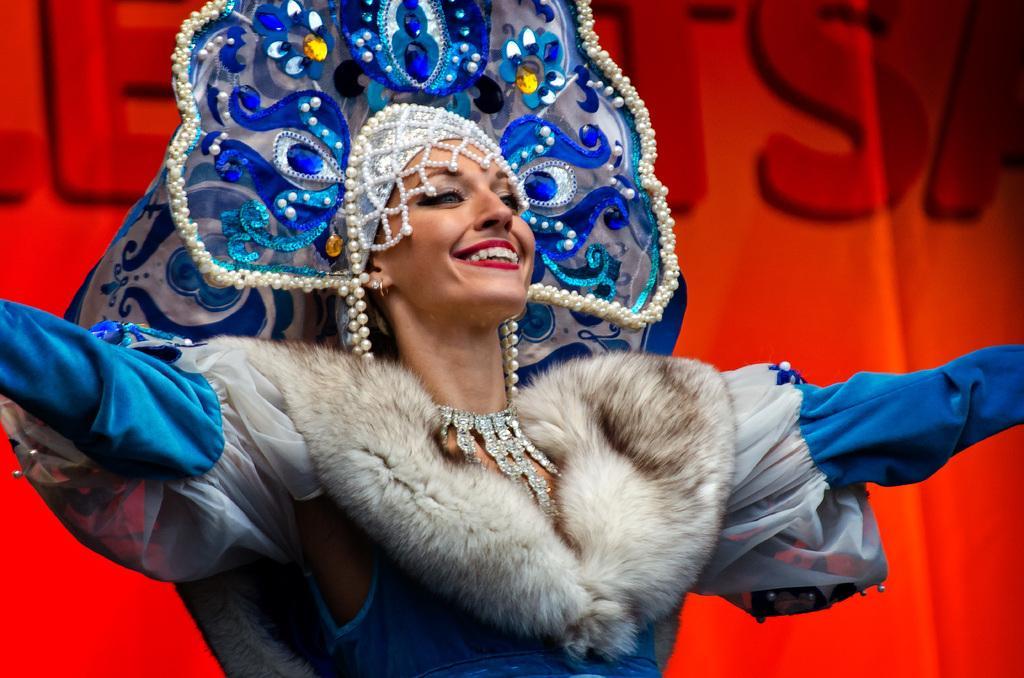Please provide a concise description of this image. In this image I can see in the middle it looks like a woman is wearing the costume and also she is wearing a crown. 